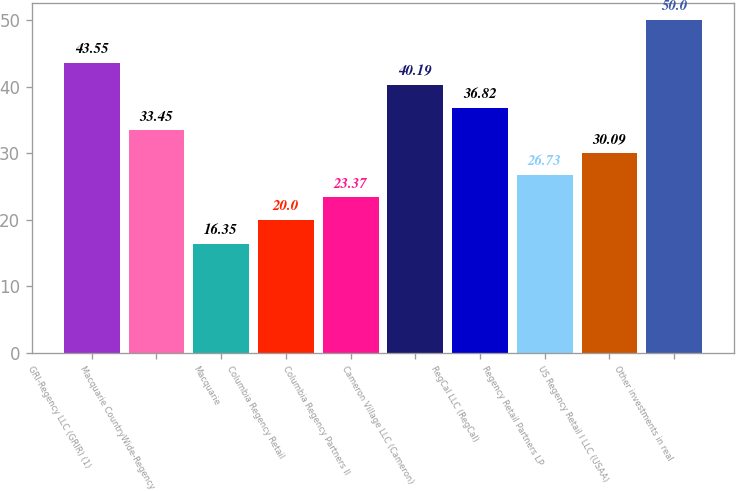Convert chart to OTSL. <chart><loc_0><loc_0><loc_500><loc_500><bar_chart><fcel>GRI-Regency LLC (GRIR) (1)<fcel>Macquarie CountryWide-Regency<fcel>Macquarie<fcel>Columbia Regency Retail<fcel>Columbia Regency Partners II<fcel>Cameron Village LLC (Cameron)<fcel>RegCal LLC (RegCal)<fcel>Regency Retail Partners LP<fcel>US Regency Retail I LLC (USAA)<fcel>Other investments in real<nl><fcel>43.55<fcel>33.45<fcel>16.35<fcel>20<fcel>23.37<fcel>40.19<fcel>36.82<fcel>26.73<fcel>30.09<fcel>50<nl></chart> 